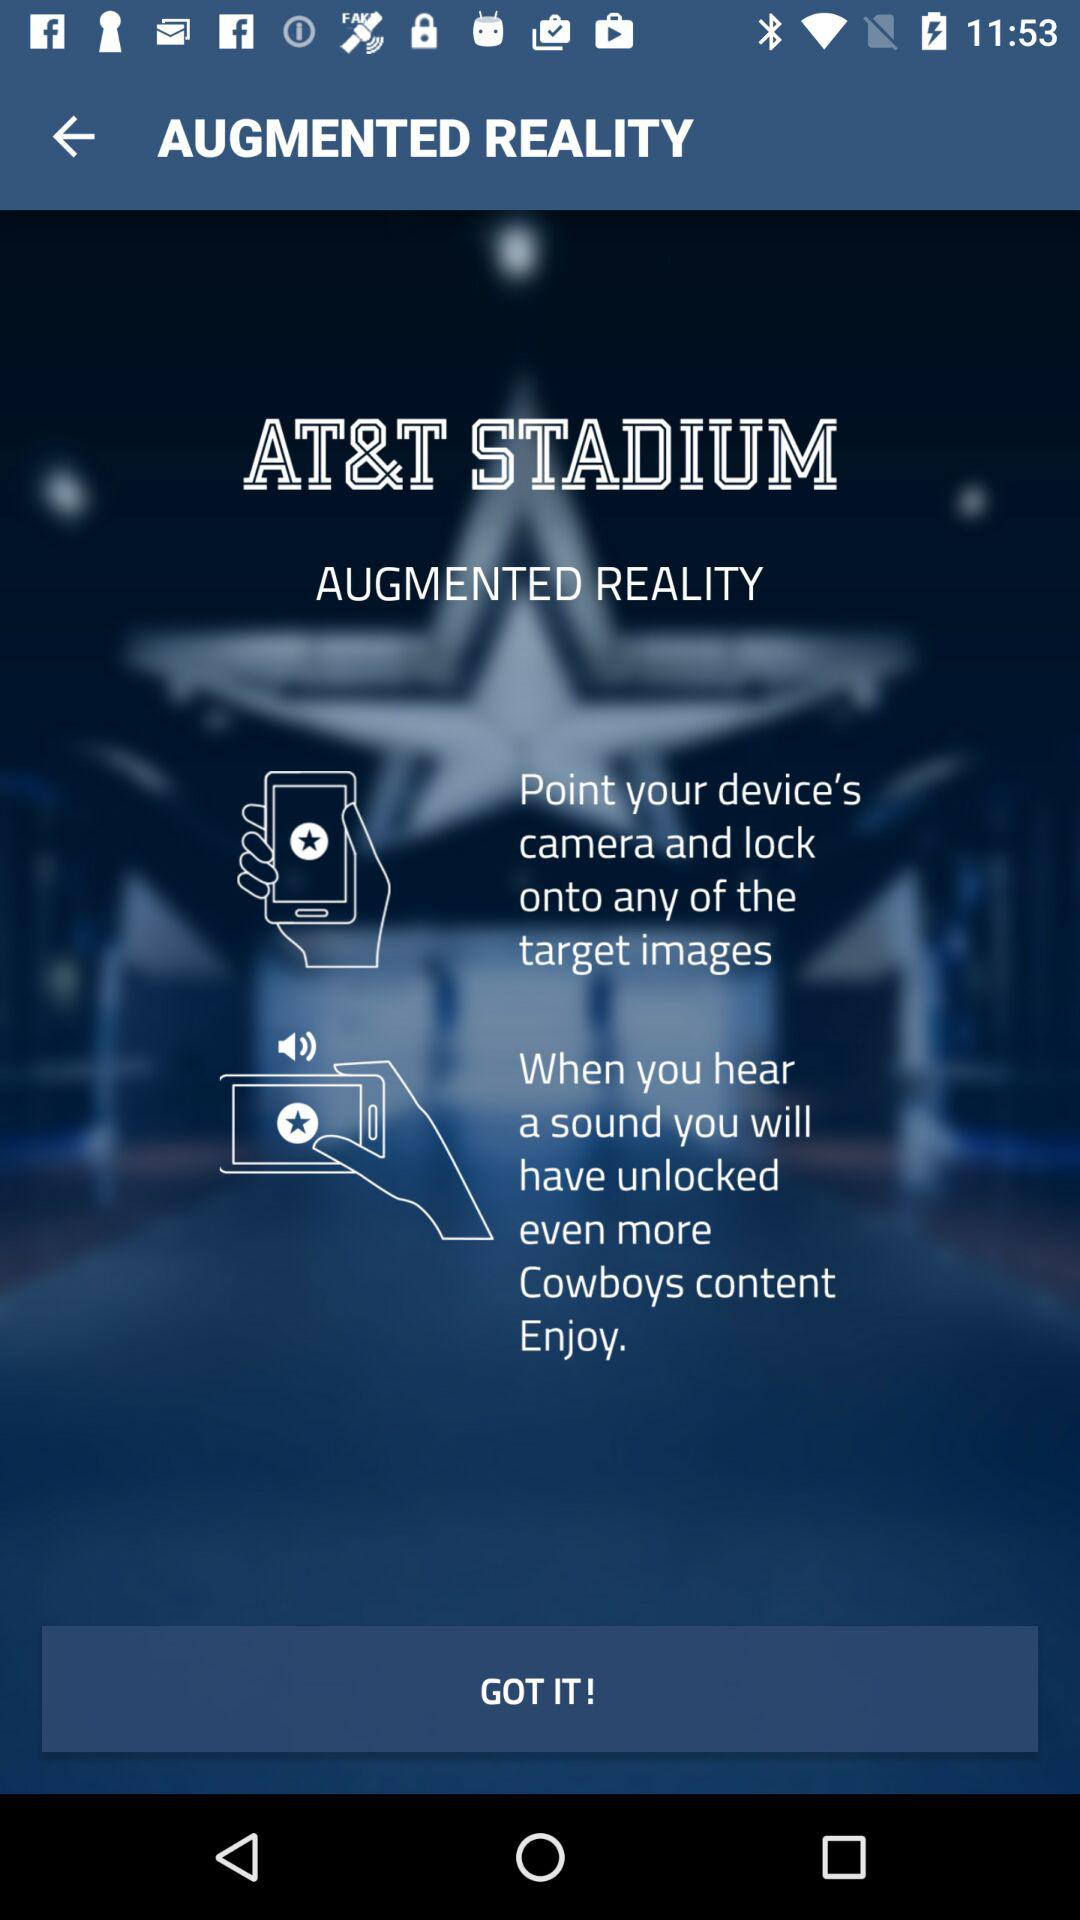What is the application name? The name of the application is "AT&T STADIUM". 